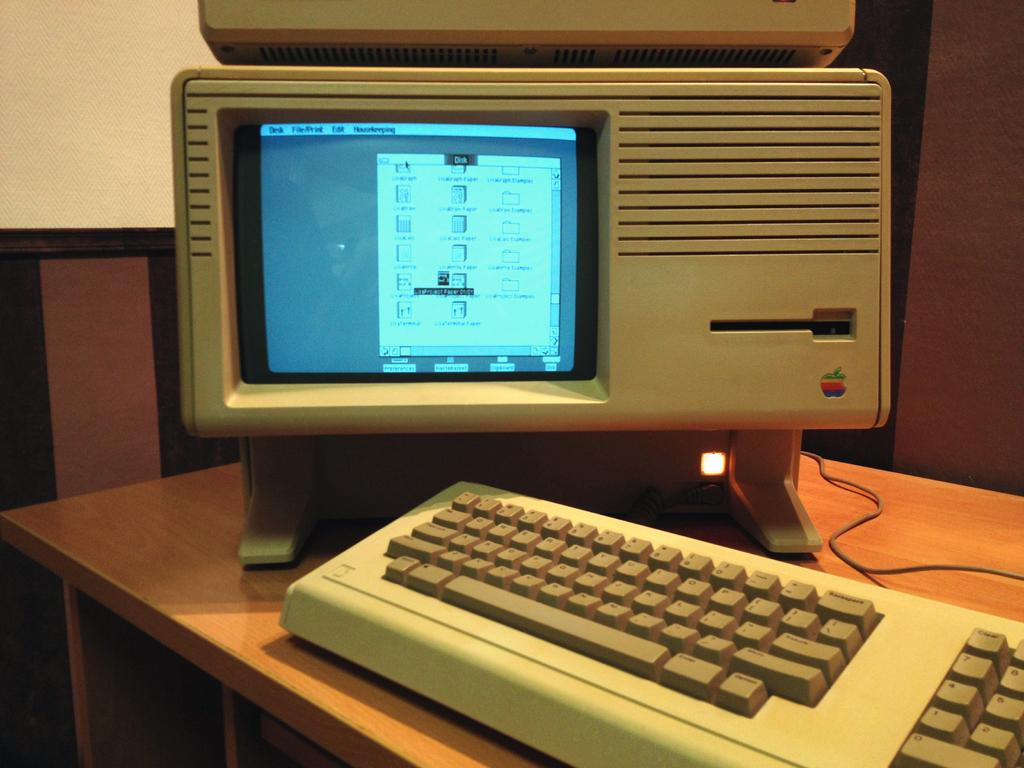<image>
Provide a brief description of the given image. An old apple computer monitor and keyboard with the numbers 7,4,1,0,8,5, and 2 showing. 